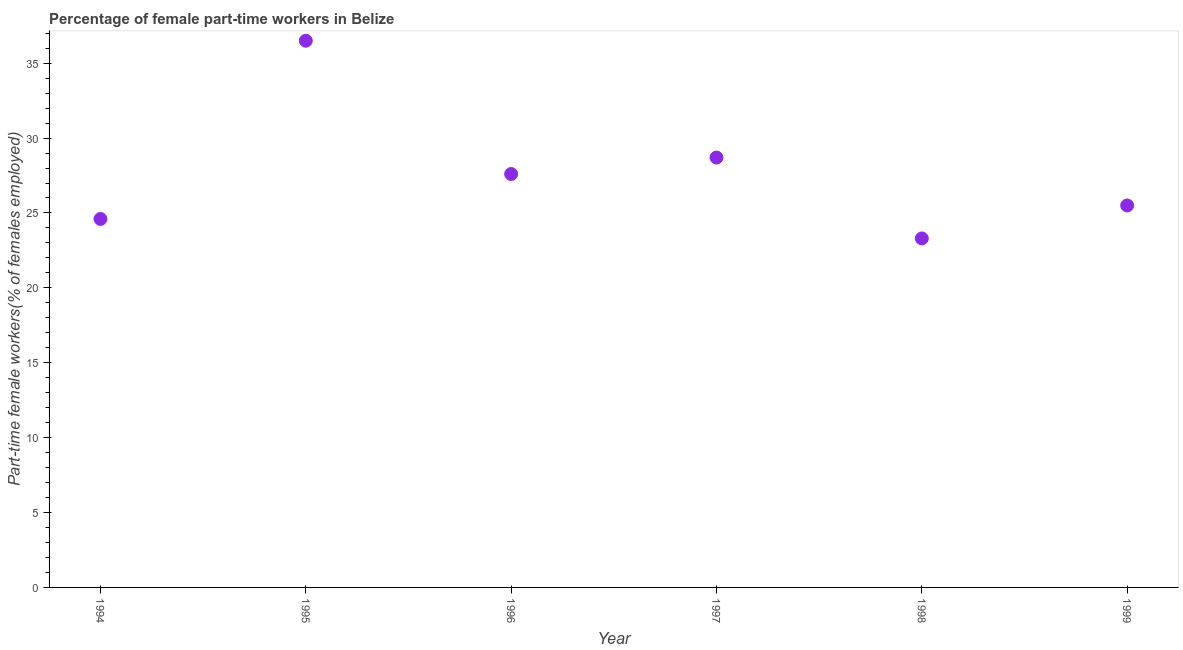What is the percentage of part-time female workers in 1996?
Make the answer very short. 27.6. Across all years, what is the maximum percentage of part-time female workers?
Your response must be concise. 36.5. Across all years, what is the minimum percentage of part-time female workers?
Make the answer very short. 23.3. In which year was the percentage of part-time female workers maximum?
Offer a terse response. 1995. What is the sum of the percentage of part-time female workers?
Your response must be concise. 166.2. What is the difference between the percentage of part-time female workers in 1995 and 1999?
Your answer should be compact. 11. What is the average percentage of part-time female workers per year?
Make the answer very short. 27.7. What is the median percentage of part-time female workers?
Provide a succinct answer. 26.55. Do a majority of the years between 1999 and 1997 (inclusive) have percentage of part-time female workers greater than 32 %?
Offer a very short reply. No. What is the ratio of the percentage of part-time female workers in 1995 to that in 1999?
Your answer should be very brief. 1.43. Is the percentage of part-time female workers in 1996 less than that in 1999?
Keep it short and to the point. No. Is the difference between the percentage of part-time female workers in 1994 and 1998 greater than the difference between any two years?
Offer a terse response. No. What is the difference between the highest and the second highest percentage of part-time female workers?
Offer a very short reply. 7.8. What is the difference between the highest and the lowest percentage of part-time female workers?
Ensure brevity in your answer.  13.2. In how many years, is the percentage of part-time female workers greater than the average percentage of part-time female workers taken over all years?
Your answer should be very brief. 2. How many dotlines are there?
Provide a succinct answer. 1. Does the graph contain any zero values?
Keep it short and to the point. No. Does the graph contain grids?
Your answer should be very brief. No. What is the title of the graph?
Offer a very short reply. Percentage of female part-time workers in Belize. What is the label or title of the X-axis?
Provide a succinct answer. Year. What is the label or title of the Y-axis?
Ensure brevity in your answer.  Part-time female workers(% of females employed). What is the Part-time female workers(% of females employed) in 1994?
Your answer should be compact. 24.6. What is the Part-time female workers(% of females employed) in 1995?
Give a very brief answer. 36.5. What is the Part-time female workers(% of females employed) in 1996?
Your answer should be very brief. 27.6. What is the Part-time female workers(% of females employed) in 1997?
Keep it short and to the point. 28.7. What is the Part-time female workers(% of females employed) in 1998?
Make the answer very short. 23.3. What is the difference between the Part-time female workers(% of females employed) in 1994 and 1995?
Keep it short and to the point. -11.9. What is the difference between the Part-time female workers(% of females employed) in 1994 and 1996?
Your response must be concise. -3. What is the difference between the Part-time female workers(% of females employed) in 1994 and 1997?
Your answer should be compact. -4.1. What is the difference between the Part-time female workers(% of females employed) in 1994 and 1999?
Make the answer very short. -0.9. What is the difference between the Part-time female workers(% of females employed) in 1995 and 1997?
Your response must be concise. 7.8. What is the difference between the Part-time female workers(% of females employed) in 1995 and 1998?
Your answer should be compact. 13.2. What is the difference between the Part-time female workers(% of females employed) in 1995 and 1999?
Your answer should be very brief. 11. What is the difference between the Part-time female workers(% of females employed) in 1997 and 1998?
Your answer should be compact. 5.4. What is the difference between the Part-time female workers(% of females employed) in 1997 and 1999?
Provide a short and direct response. 3.2. What is the difference between the Part-time female workers(% of females employed) in 1998 and 1999?
Provide a succinct answer. -2.2. What is the ratio of the Part-time female workers(% of females employed) in 1994 to that in 1995?
Your response must be concise. 0.67. What is the ratio of the Part-time female workers(% of females employed) in 1994 to that in 1996?
Keep it short and to the point. 0.89. What is the ratio of the Part-time female workers(% of females employed) in 1994 to that in 1997?
Give a very brief answer. 0.86. What is the ratio of the Part-time female workers(% of females employed) in 1994 to that in 1998?
Give a very brief answer. 1.06. What is the ratio of the Part-time female workers(% of females employed) in 1995 to that in 1996?
Your response must be concise. 1.32. What is the ratio of the Part-time female workers(% of females employed) in 1995 to that in 1997?
Offer a very short reply. 1.27. What is the ratio of the Part-time female workers(% of females employed) in 1995 to that in 1998?
Make the answer very short. 1.57. What is the ratio of the Part-time female workers(% of females employed) in 1995 to that in 1999?
Provide a succinct answer. 1.43. What is the ratio of the Part-time female workers(% of females employed) in 1996 to that in 1998?
Keep it short and to the point. 1.19. What is the ratio of the Part-time female workers(% of females employed) in 1996 to that in 1999?
Make the answer very short. 1.08. What is the ratio of the Part-time female workers(% of females employed) in 1997 to that in 1998?
Provide a short and direct response. 1.23. What is the ratio of the Part-time female workers(% of females employed) in 1997 to that in 1999?
Your response must be concise. 1.12. What is the ratio of the Part-time female workers(% of females employed) in 1998 to that in 1999?
Make the answer very short. 0.91. 